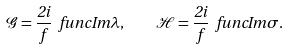<formula> <loc_0><loc_0><loc_500><loc_500>\mathcal { G } = \frac { 2 i } { f } \ f u n c { I m } \lambda , \quad \mathcal { H } = \frac { 2 i } { f } \ f u n c { I m } \sigma .</formula> 